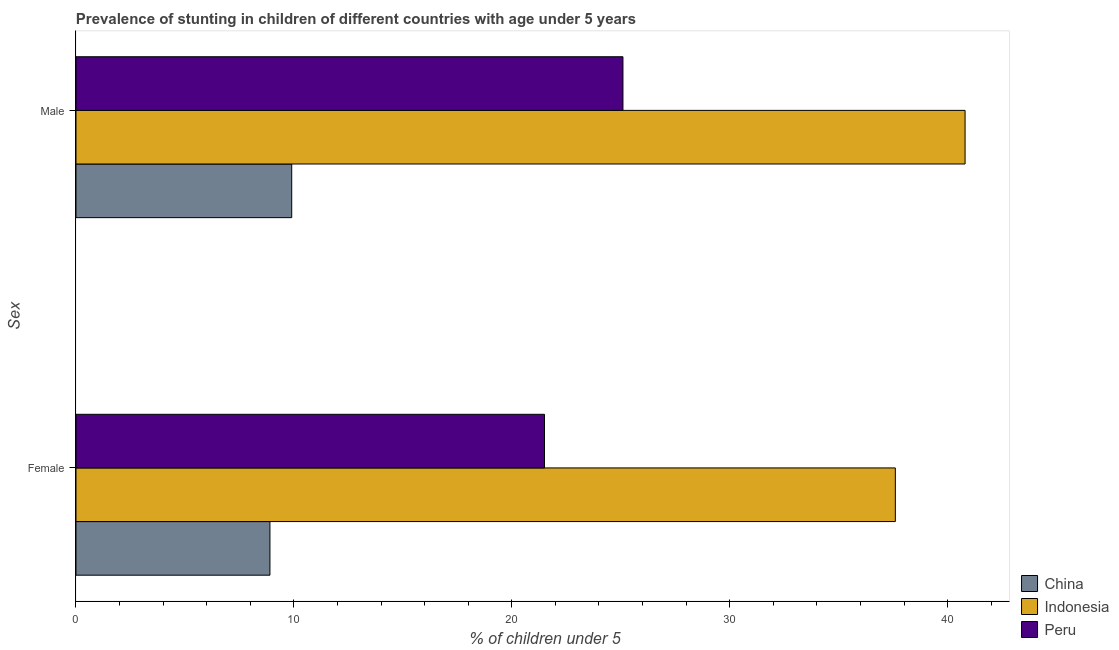How many different coloured bars are there?
Ensure brevity in your answer.  3. Are the number of bars on each tick of the Y-axis equal?
Keep it short and to the point. Yes. How many bars are there on the 2nd tick from the top?
Provide a short and direct response. 3. What is the percentage of stunted male children in Indonesia?
Provide a succinct answer. 40.8. Across all countries, what is the maximum percentage of stunted female children?
Provide a short and direct response. 37.6. Across all countries, what is the minimum percentage of stunted female children?
Ensure brevity in your answer.  8.9. In which country was the percentage of stunted female children minimum?
Offer a very short reply. China. What is the total percentage of stunted male children in the graph?
Your answer should be very brief. 75.8. What is the difference between the percentage of stunted male children in China and that in Indonesia?
Your answer should be compact. -30.9. What is the difference between the percentage of stunted female children in China and the percentage of stunted male children in Peru?
Offer a terse response. -16.2. What is the average percentage of stunted female children per country?
Offer a terse response. 22.67. What is the difference between the percentage of stunted female children and percentage of stunted male children in Peru?
Your answer should be compact. -3.6. In how many countries, is the percentage of stunted female children greater than 30 %?
Give a very brief answer. 1. What is the ratio of the percentage of stunted female children in Indonesia to that in China?
Ensure brevity in your answer.  4.22. Is the percentage of stunted male children in Indonesia less than that in Peru?
Give a very brief answer. No. In how many countries, is the percentage of stunted male children greater than the average percentage of stunted male children taken over all countries?
Make the answer very short. 1. What does the 3rd bar from the top in Male represents?
Provide a short and direct response. China. What does the 3rd bar from the bottom in Male represents?
Give a very brief answer. Peru. How many countries are there in the graph?
Ensure brevity in your answer.  3. What is the difference between two consecutive major ticks on the X-axis?
Provide a short and direct response. 10. Does the graph contain grids?
Provide a short and direct response. No. How many legend labels are there?
Offer a very short reply. 3. How are the legend labels stacked?
Give a very brief answer. Vertical. What is the title of the graph?
Provide a short and direct response. Prevalence of stunting in children of different countries with age under 5 years. What is the label or title of the X-axis?
Your answer should be compact.  % of children under 5. What is the label or title of the Y-axis?
Provide a short and direct response. Sex. What is the  % of children under 5 of China in Female?
Your response must be concise. 8.9. What is the  % of children under 5 in Indonesia in Female?
Keep it short and to the point. 37.6. What is the  % of children under 5 of Peru in Female?
Ensure brevity in your answer.  21.5. What is the  % of children under 5 of China in Male?
Make the answer very short. 9.9. What is the  % of children under 5 in Indonesia in Male?
Offer a very short reply. 40.8. What is the  % of children under 5 in Peru in Male?
Provide a succinct answer. 25.1. Across all Sex, what is the maximum  % of children under 5 in China?
Your response must be concise. 9.9. Across all Sex, what is the maximum  % of children under 5 of Indonesia?
Provide a short and direct response. 40.8. Across all Sex, what is the maximum  % of children under 5 in Peru?
Offer a very short reply. 25.1. Across all Sex, what is the minimum  % of children under 5 of China?
Make the answer very short. 8.9. Across all Sex, what is the minimum  % of children under 5 in Indonesia?
Give a very brief answer. 37.6. Across all Sex, what is the minimum  % of children under 5 in Peru?
Give a very brief answer. 21.5. What is the total  % of children under 5 of China in the graph?
Provide a short and direct response. 18.8. What is the total  % of children under 5 in Indonesia in the graph?
Your response must be concise. 78.4. What is the total  % of children under 5 of Peru in the graph?
Make the answer very short. 46.6. What is the difference between the  % of children under 5 of China in Female and the  % of children under 5 of Indonesia in Male?
Ensure brevity in your answer.  -31.9. What is the difference between the  % of children under 5 in China in Female and the  % of children under 5 in Peru in Male?
Give a very brief answer. -16.2. What is the difference between the  % of children under 5 in Indonesia in Female and the  % of children under 5 in Peru in Male?
Offer a very short reply. 12.5. What is the average  % of children under 5 of China per Sex?
Provide a succinct answer. 9.4. What is the average  % of children under 5 in Indonesia per Sex?
Offer a very short reply. 39.2. What is the average  % of children under 5 in Peru per Sex?
Your answer should be very brief. 23.3. What is the difference between the  % of children under 5 in China and  % of children under 5 in Indonesia in Female?
Ensure brevity in your answer.  -28.7. What is the difference between the  % of children under 5 in Indonesia and  % of children under 5 in Peru in Female?
Your response must be concise. 16.1. What is the difference between the  % of children under 5 in China and  % of children under 5 in Indonesia in Male?
Your answer should be compact. -30.9. What is the difference between the  % of children under 5 of China and  % of children under 5 of Peru in Male?
Ensure brevity in your answer.  -15.2. What is the difference between the  % of children under 5 in Indonesia and  % of children under 5 in Peru in Male?
Make the answer very short. 15.7. What is the ratio of the  % of children under 5 of China in Female to that in Male?
Provide a succinct answer. 0.9. What is the ratio of the  % of children under 5 in Indonesia in Female to that in Male?
Offer a terse response. 0.92. What is the ratio of the  % of children under 5 in Peru in Female to that in Male?
Make the answer very short. 0.86. What is the difference between the highest and the second highest  % of children under 5 of China?
Give a very brief answer. 1. What is the difference between the highest and the second highest  % of children under 5 of Indonesia?
Ensure brevity in your answer.  3.2. 